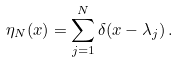Convert formula to latex. <formula><loc_0><loc_0><loc_500><loc_500>\eta _ { N } ( x ) = \sum ^ { N } _ { j = 1 } \delta ( x - \lambda _ { j } ) \, .</formula> 